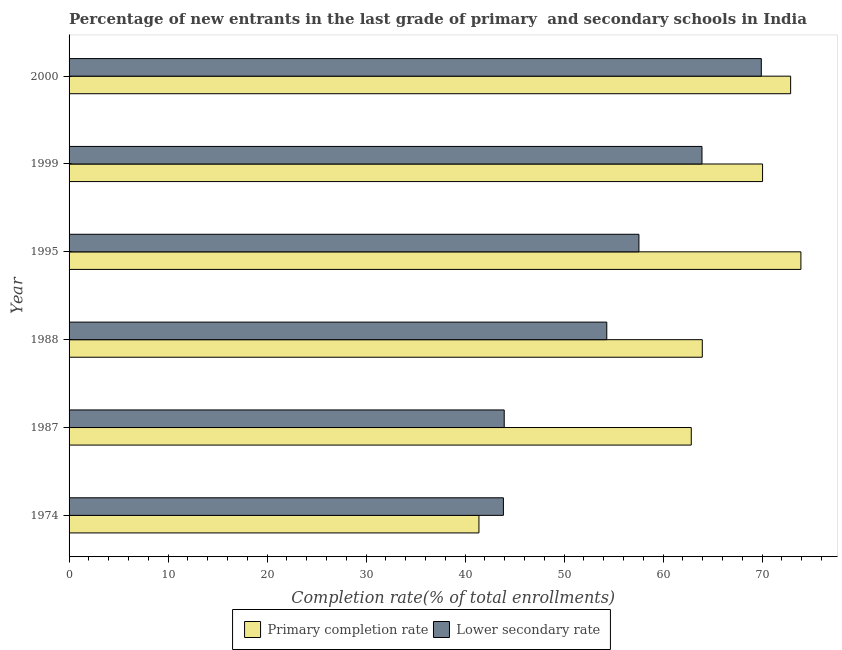How many different coloured bars are there?
Ensure brevity in your answer.  2. How many groups of bars are there?
Make the answer very short. 6. Are the number of bars per tick equal to the number of legend labels?
Provide a succinct answer. Yes. How many bars are there on the 2nd tick from the top?
Keep it short and to the point. 2. How many bars are there on the 5th tick from the bottom?
Your answer should be compact. 2. In how many cases, is the number of bars for a given year not equal to the number of legend labels?
Provide a short and direct response. 0. What is the completion rate in primary schools in 2000?
Provide a succinct answer. 72.88. Across all years, what is the maximum completion rate in primary schools?
Offer a terse response. 73.92. Across all years, what is the minimum completion rate in primary schools?
Your answer should be very brief. 41.4. In which year was the completion rate in secondary schools maximum?
Provide a succinct answer. 2000. In which year was the completion rate in primary schools minimum?
Provide a succinct answer. 1974. What is the total completion rate in primary schools in the graph?
Your answer should be very brief. 385.06. What is the difference between the completion rate in secondary schools in 1974 and that in 2000?
Give a very brief answer. -26.05. What is the difference between the completion rate in primary schools in 2000 and the completion rate in secondary schools in 1988?
Provide a short and direct response. 18.57. What is the average completion rate in secondary schools per year?
Your answer should be very brief. 55.59. In the year 1974, what is the difference between the completion rate in primary schools and completion rate in secondary schools?
Provide a short and direct response. -2.47. What is the ratio of the completion rate in primary schools in 1988 to that in 1999?
Your answer should be very brief. 0.91. Is the difference between the completion rate in secondary schools in 1987 and 1988 greater than the difference between the completion rate in primary schools in 1987 and 1988?
Your response must be concise. No. What is the difference between the highest and the second highest completion rate in primary schools?
Keep it short and to the point. 1.04. What is the difference between the highest and the lowest completion rate in primary schools?
Offer a terse response. 32.52. What does the 2nd bar from the top in 1995 represents?
Your answer should be compact. Primary completion rate. What does the 1st bar from the bottom in 1988 represents?
Your answer should be compact. Primary completion rate. Are all the bars in the graph horizontal?
Your response must be concise. Yes. Are the values on the major ticks of X-axis written in scientific E-notation?
Your response must be concise. No. Does the graph contain any zero values?
Ensure brevity in your answer.  No. Does the graph contain grids?
Make the answer very short. No. Where does the legend appear in the graph?
Ensure brevity in your answer.  Bottom center. What is the title of the graph?
Ensure brevity in your answer.  Percentage of new entrants in the last grade of primary  and secondary schools in India. Does "Adolescent fertility rate" appear as one of the legend labels in the graph?
Keep it short and to the point. No. What is the label or title of the X-axis?
Offer a terse response. Completion rate(% of total enrollments). What is the label or title of the Y-axis?
Your answer should be compact. Year. What is the Completion rate(% of total enrollments) of Primary completion rate in 1974?
Your response must be concise. 41.4. What is the Completion rate(% of total enrollments) of Lower secondary rate in 1974?
Give a very brief answer. 43.87. What is the Completion rate(% of total enrollments) in Primary completion rate in 1987?
Your response must be concise. 62.85. What is the Completion rate(% of total enrollments) in Lower secondary rate in 1987?
Provide a succinct answer. 43.95. What is the Completion rate(% of total enrollments) in Primary completion rate in 1988?
Your answer should be compact. 63.96. What is the Completion rate(% of total enrollments) of Lower secondary rate in 1988?
Provide a succinct answer. 54.31. What is the Completion rate(% of total enrollments) in Primary completion rate in 1995?
Give a very brief answer. 73.92. What is the Completion rate(% of total enrollments) in Lower secondary rate in 1995?
Keep it short and to the point. 57.56. What is the Completion rate(% of total enrollments) of Primary completion rate in 1999?
Offer a terse response. 70.05. What is the Completion rate(% of total enrollments) in Lower secondary rate in 1999?
Your response must be concise. 63.93. What is the Completion rate(% of total enrollments) in Primary completion rate in 2000?
Make the answer very short. 72.88. What is the Completion rate(% of total enrollments) in Lower secondary rate in 2000?
Keep it short and to the point. 69.92. Across all years, what is the maximum Completion rate(% of total enrollments) of Primary completion rate?
Your response must be concise. 73.92. Across all years, what is the maximum Completion rate(% of total enrollments) of Lower secondary rate?
Your answer should be compact. 69.92. Across all years, what is the minimum Completion rate(% of total enrollments) of Primary completion rate?
Your answer should be very brief. 41.4. Across all years, what is the minimum Completion rate(% of total enrollments) of Lower secondary rate?
Your response must be concise. 43.87. What is the total Completion rate(% of total enrollments) in Primary completion rate in the graph?
Your response must be concise. 385.06. What is the total Completion rate(% of total enrollments) of Lower secondary rate in the graph?
Offer a very short reply. 333.55. What is the difference between the Completion rate(% of total enrollments) in Primary completion rate in 1974 and that in 1987?
Ensure brevity in your answer.  -21.45. What is the difference between the Completion rate(% of total enrollments) in Lower secondary rate in 1974 and that in 1987?
Your response must be concise. -0.08. What is the difference between the Completion rate(% of total enrollments) of Primary completion rate in 1974 and that in 1988?
Your response must be concise. -22.56. What is the difference between the Completion rate(% of total enrollments) in Lower secondary rate in 1974 and that in 1988?
Keep it short and to the point. -10.44. What is the difference between the Completion rate(% of total enrollments) of Primary completion rate in 1974 and that in 1995?
Give a very brief answer. -32.52. What is the difference between the Completion rate(% of total enrollments) in Lower secondary rate in 1974 and that in 1995?
Make the answer very short. -13.69. What is the difference between the Completion rate(% of total enrollments) in Primary completion rate in 1974 and that in 1999?
Your response must be concise. -28.65. What is the difference between the Completion rate(% of total enrollments) in Lower secondary rate in 1974 and that in 1999?
Give a very brief answer. -20.06. What is the difference between the Completion rate(% of total enrollments) in Primary completion rate in 1974 and that in 2000?
Provide a succinct answer. -31.49. What is the difference between the Completion rate(% of total enrollments) in Lower secondary rate in 1974 and that in 2000?
Keep it short and to the point. -26.05. What is the difference between the Completion rate(% of total enrollments) in Primary completion rate in 1987 and that in 1988?
Provide a short and direct response. -1.11. What is the difference between the Completion rate(% of total enrollments) in Lower secondary rate in 1987 and that in 1988?
Your answer should be compact. -10.36. What is the difference between the Completion rate(% of total enrollments) in Primary completion rate in 1987 and that in 1995?
Offer a terse response. -11.07. What is the difference between the Completion rate(% of total enrollments) in Lower secondary rate in 1987 and that in 1995?
Provide a succinct answer. -13.61. What is the difference between the Completion rate(% of total enrollments) of Primary completion rate in 1987 and that in 1999?
Give a very brief answer. -7.2. What is the difference between the Completion rate(% of total enrollments) in Lower secondary rate in 1987 and that in 1999?
Keep it short and to the point. -19.98. What is the difference between the Completion rate(% of total enrollments) of Primary completion rate in 1987 and that in 2000?
Your response must be concise. -10.04. What is the difference between the Completion rate(% of total enrollments) of Lower secondary rate in 1987 and that in 2000?
Offer a terse response. -25.97. What is the difference between the Completion rate(% of total enrollments) of Primary completion rate in 1988 and that in 1995?
Offer a very short reply. -9.96. What is the difference between the Completion rate(% of total enrollments) in Lower secondary rate in 1988 and that in 1995?
Give a very brief answer. -3.25. What is the difference between the Completion rate(% of total enrollments) of Primary completion rate in 1988 and that in 1999?
Ensure brevity in your answer.  -6.09. What is the difference between the Completion rate(% of total enrollments) of Lower secondary rate in 1988 and that in 1999?
Keep it short and to the point. -9.62. What is the difference between the Completion rate(% of total enrollments) in Primary completion rate in 1988 and that in 2000?
Give a very brief answer. -8.92. What is the difference between the Completion rate(% of total enrollments) of Lower secondary rate in 1988 and that in 2000?
Your response must be concise. -15.61. What is the difference between the Completion rate(% of total enrollments) in Primary completion rate in 1995 and that in 1999?
Offer a very short reply. 3.87. What is the difference between the Completion rate(% of total enrollments) of Lower secondary rate in 1995 and that in 1999?
Ensure brevity in your answer.  -6.37. What is the difference between the Completion rate(% of total enrollments) in Primary completion rate in 1995 and that in 2000?
Your response must be concise. 1.04. What is the difference between the Completion rate(% of total enrollments) in Lower secondary rate in 1995 and that in 2000?
Your response must be concise. -12.36. What is the difference between the Completion rate(% of total enrollments) in Primary completion rate in 1999 and that in 2000?
Give a very brief answer. -2.84. What is the difference between the Completion rate(% of total enrollments) in Lower secondary rate in 1999 and that in 2000?
Give a very brief answer. -5.99. What is the difference between the Completion rate(% of total enrollments) of Primary completion rate in 1974 and the Completion rate(% of total enrollments) of Lower secondary rate in 1987?
Your answer should be compact. -2.55. What is the difference between the Completion rate(% of total enrollments) of Primary completion rate in 1974 and the Completion rate(% of total enrollments) of Lower secondary rate in 1988?
Your answer should be very brief. -12.91. What is the difference between the Completion rate(% of total enrollments) of Primary completion rate in 1974 and the Completion rate(% of total enrollments) of Lower secondary rate in 1995?
Provide a short and direct response. -16.16. What is the difference between the Completion rate(% of total enrollments) in Primary completion rate in 1974 and the Completion rate(% of total enrollments) in Lower secondary rate in 1999?
Your response must be concise. -22.53. What is the difference between the Completion rate(% of total enrollments) in Primary completion rate in 1974 and the Completion rate(% of total enrollments) in Lower secondary rate in 2000?
Offer a terse response. -28.52. What is the difference between the Completion rate(% of total enrollments) in Primary completion rate in 1987 and the Completion rate(% of total enrollments) in Lower secondary rate in 1988?
Your answer should be very brief. 8.53. What is the difference between the Completion rate(% of total enrollments) of Primary completion rate in 1987 and the Completion rate(% of total enrollments) of Lower secondary rate in 1995?
Give a very brief answer. 5.29. What is the difference between the Completion rate(% of total enrollments) of Primary completion rate in 1987 and the Completion rate(% of total enrollments) of Lower secondary rate in 1999?
Offer a terse response. -1.08. What is the difference between the Completion rate(% of total enrollments) of Primary completion rate in 1987 and the Completion rate(% of total enrollments) of Lower secondary rate in 2000?
Your answer should be compact. -7.08. What is the difference between the Completion rate(% of total enrollments) in Primary completion rate in 1988 and the Completion rate(% of total enrollments) in Lower secondary rate in 1995?
Ensure brevity in your answer.  6.4. What is the difference between the Completion rate(% of total enrollments) of Primary completion rate in 1988 and the Completion rate(% of total enrollments) of Lower secondary rate in 1999?
Your response must be concise. 0.03. What is the difference between the Completion rate(% of total enrollments) in Primary completion rate in 1988 and the Completion rate(% of total enrollments) in Lower secondary rate in 2000?
Offer a very short reply. -5.96. What is the difference between the Completion rate(% of total enrollments) in Primary completion rate in 1995 and the Completion rate(% of total enrollments) in Lower secondary rate in 1999?
Offer a very short reply. 9.99. What is the difference between the Completion rate(% of total enrollments) in Primary completion rate in 1995 and the Completion rate(% of total enrollments) in Lower secondary rate in 2000?
Offer a terse response. 4. What is the difference between the Completion rate(% of total enrollments) in Primary completion rate in 1999 and the Completion rate(% of total enrollments) in Lower secondary rate in 2000?
Offer a very short reply. 0.13. What is the average Completion rate(% of total enrollments) in Primary completion rate per year?
Your response must be concise. 64.18. What is the average Completion rate(% of total enrollments) of Lower secondary rate per year?
Provide a short and direct response. 55.59. In the year 1974, what is the difference between the Completion rate(% of total enrollments) in Primary completion rate and Completion rate(% of total enrollments) in Lower secondary rate?
Your answer should be very brief. -2.47. In the year 1987, what is the difference between the Completion rate(% of total enrollments) in Primary completion rate and Completion rate(% of total enrollments) in Lower secondary rate?
Your response must be concise. 18.89. In the year 1988, what is the difference between the Completion rate(% of total enrollments) in Primary completion rate and Completion rate(% of total enrollments) in Lower secondary rate?
Your answer should be compact. 9.65. In the year 1995, what is the difference between the Completion rate(% of total enrollments) of Primary completion rate and Completion rate(% of total enrollments) of Lower secondary rate?
Ensure brevity in your answer.  16.36. In the year 1999, what is the difference between the Completion rate(% of total enrollments) of Primary completion rate and Completion rate(% of total enrollments) of Lower secondary rate?
Keep it short and to the point. 6.12. In the year 2000, what is the difference between the Completion rate(% of total enrollments) of Primary completion rate and Completion rate(% of total enrollments) of Lower secondary rate?
Your answer should be very brief. 2.96. What is the ratio of the Completion rate(% of total enrollments) in Primary completion rate in 1974 to that in 1987?
Offer a terse response. 0.66. What is the ratio of the Completion rate(% of total enrollments) in Primary completion rate in 1974 to that in 1988?
Give a very brief answer. 0.65. What is the ratio of the Completion rate(% of total enrollments) of Lower secondary rate in 1974 to that in 1988?
Your answer should be compact. 0.81. What is the ratio of the Completion rate(% of total enrollments) of Primary completion rate in 1974 to that in 1995?
Your answer should be compact. 0.56. What is the ratio of the Completion rate(% of total enrollments) in Lower secondary rate in 1974 to that in 1995?
Keep it short and to the point. 0.76. What is the ratio of the Completion rate(% of total enrollments) of Primary completion rate in 1974 to that in 1999?
Give a very brief answer. 0.59. What is the ratio of the Completion rate(% of total enrollments) in Lower secondary rate in 1974 to that in 1999?
Provide a succinct answer. 0.69. What is the ratio of the Completion rate(% of total enrollments) in Primary completion rate in 1974 to that in 2000?
Your answer should be compact. 0.57. What is the ratio of the Completion rate(% of total enrollments) in Lower secondary rate in 1974 to that in 2000?
Offer a terse response. 0.63. What is the ratio of the Completion rate(% of total enrollments) in Primary completion rate in 1987 to that in 1988?
Provide a succinct answer. 0.98. What is the ratio of the Completion rate(% of total enrollments) of Lower secondary rate in 1987 to that in 1988?
Provide a short and direct response. 0.81. What is the ratio of the Completion rate(% of total enrollments) of Primary completion rate in 1987 to that in 1995?
Give a very brief answer. 0.85. What is the ratio of the Completion rate(% of total enrollments) in Lower secondary rate in 1987 to that in 1995?
Offer a terse response. 0.76. What is the ratio of the Completion rate(% of total enrollments) in Primary completion rate in 1987 to that in 1999?
Ensure brevity in your answer.  0.9. What is the ratio of the Completion rate(% of total enrollments) of Lower secondary rate in 1987 to that in 1999?
Provide a short and direct response. 0.69. What is the ratio of the Completion rate(% of total enrollments) of Primary completion rate in 1987 to that in 2000?
Offer a terse response. 0.86. What is the ratio of the Completion rate(% of total enrollments) of Lower secondary rate in 1987 to that in 2000?
Keep it short and to the point. 0.63. What is the ratio of the Completion rate(% of total enrollments) of Primary completion rate in 1988 to that in 1995?
Your answer should be very brief. 0.87. What is the ratio of the Completion rate(% of total enrollments) in Lower secondary rate in 1988 to that in 1995?
Your response must be concise. 0.94. What is the ratio of the Completion rate(% of total enrollments) of Primary completion rate in 1988 to that in 1999?
Offer a very short reply. 0.91. What is the ratio of the Completion rate(% of total enrollments) in Lower secondary rate in 1988 to that in 1999?
Your response must be concise. 0.85. What is the ratio of the Completion rate(% of total enrollments) in Primary completion rate in 1988 to that in 2000?
Provide a short and direct response. 0.88. What is the ratio of the Completion rate(% of total enrollments) in Lower secondary rate in 1988 to that in 2000?
Offer a very short reply. 0.78. What is the ratio of the Completion rate(% of total enrollments) in Primary completion rate in 1995 to that in 1999?
Keep it short and to the point. 1.06. What is the ratio of the Completion rate(% of total enrollments) in Lower secondary rate in 1995 to that in 1999?
Provide a succinct answer. 0.9. What is the ratio of the Completion rate(% of total enrollments) of Primary completion rate in 1995 to that in 2000?
Your answer should be very brief. 1.01. What is the ratio of the Completion rate(% of total enrollments) of Lower secondary rate in 1995 to that in 2000?
Your answer should be very brief. 0.82. What is the ratio of the Completion rate(% of total enrollments) of Primary completion rate in 1999 to that in 2000?
Offer a terse response. 0.96. What is the ratio of the Completion rate(% of total enrollments) of Lower secondary rate in 1999 to that in 2000?
Your response must be concise. 0.91. What is the difference between the highest and the second highest Completion rate(% of total enrollments) in Primary completion rate?
Your answer should be very brief. 1.04. What is the difference between the highest and the second highest Completion rate(% of total enrollments) in Lower secondary rate?
Offer a very short reply. 5.99. What is the difference between the highest and the lowest Completion rate(% of total enrollments) in Primary completion rate?
Provide a succinct answer. 32.52. What is the difference between the highest and the lowest Completion rate(% of total enrollments) of Lower secondary rate?
Provide a short and direct response. 26.05. 